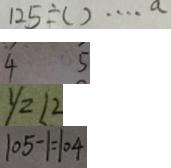<formula> <loc_0><loc_0><loc_500><loc_500>1 2 5 \div ( ) \cdots a 
 \overline { 4 } \overline { 5 } 
 y = 1 2 
 1 0 5 - 1 = 1 0 4</formula> 